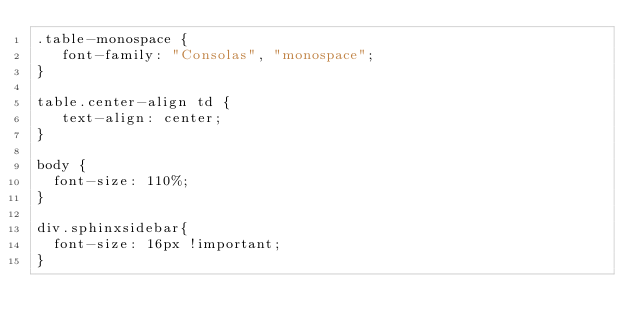Convert code to text. <code><loc_0><loc_0><loc_500><loc_500><_CSS_>.table-monospace {
   font-family: "Consolas", "monospace";
}

table.center-align td {
   text-align: center;
}

body {
	font-size: 110%;
}

div.sphinxsidebar{
	font-size: 16px !important;
}</code> 